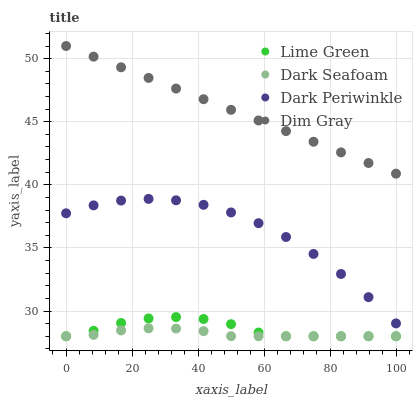Does Dark Seafoam have the minimum area under the curve?
Answer yes or no. Yes. Does Dim Gray have the maximum area under the curve?
Answer yes or no. Yes. Does Lime Green have the minimum area under the curve?
Answer yes or no. No. Does Lime Green have the maximum area under the curve?
Answer yes or no. No. Is Dim Gray the smoothest?
Answer yes or no. Yes. Is Dark Periwinkle the roughest?
Answer yes or no. Yes. Is Lime Green the smoothest?
Answer yes or no. No. Is Lime Green the roughest?
Answer yes or no. No. Does Dark Seafoam have the lowest value?
Answer yes or no. Yes. Does Dim Gray have the lowest value?
Answer yes or no. No. Does Dim Gray have the highest value?
Answer yes or no. Yes. Does Lime Green have the highest value?
Answer yes or no. No. Is Dark Periwinkle less than Dim Gray?
Answer yes or no. Yes. Is Dim Gray greater than Lime Green?
Answer yes or no. Yes. Does Lime Green intersect Dark Seafoam?
Answer yes or no. Yes. Is Lime Green less than Dark Seafoam?
Answer yes or no. No. Is Lime Green greater than Dark Seafoam?
Answer yes or no. No. Does Dark Periwinkle intersect Dim Gray?
Answer yes or no. No. 